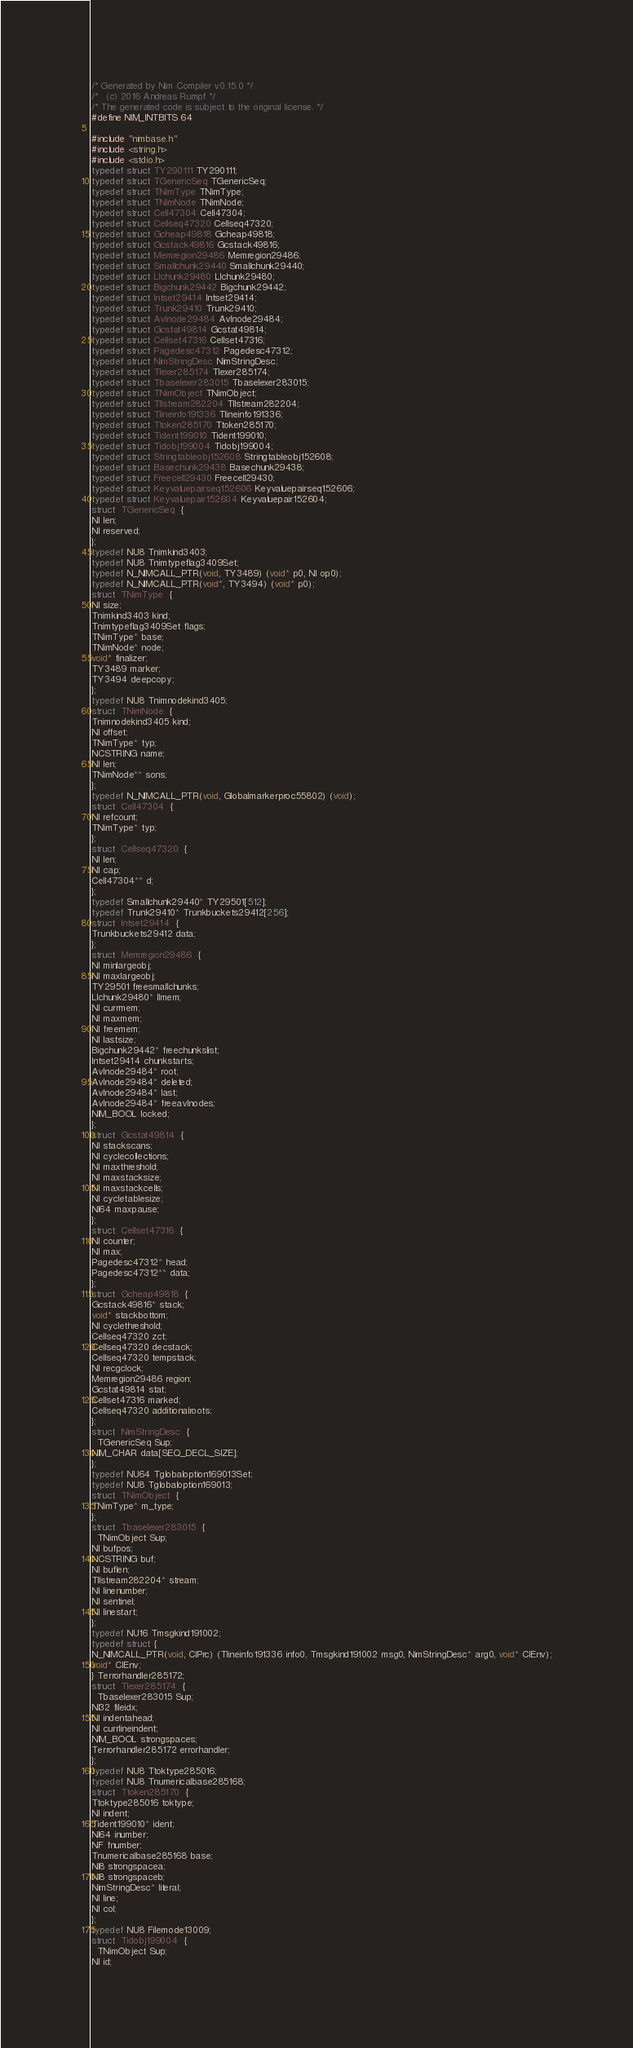Convert code to text. <code><loc_0><loc_0><loc_500><loc_500><_C_>/* Generated by Nim Compiler v0.15.0 */
/*   (c) 2016 Andreas Rumpf */
/* The generated code is subject to the original license. */
#define NIM_INTBITS 64

#include "nimbase.h"
#include <string.h>
#include <stdio.h>
typedef struct TY290111 TY290111;
typedef struct TGenericSeq TGenericSeq;
typedef struct TNimType TNimType;
typedef struct TNimNode TNimNode;
typedef struct Cell47304 Cell47304;
typedef struct Cellseq47320 Cellseq47320;
typedef struct Gcheap49818 Gcheap49818;
typedef struct Gcstack49816 Gcstack49816;
typedef struct Memregion29486 Memregion29486;
typedef struct Smallchunk29440 Smallchunk29440;
typedef struct Llchunk29480 Llchunk29480;
typedef struct Bigchunk29442 Bigchunk29442;
typedef struct Intset29414 Intset29414;
typedef struct Trunk29410 Trunk29410;
typedef struct Avlnode29484 Avlnode29484;
typedef struct Gcstat49814 Gcstat49814;
typedef struct Cellset47316 Cellset47316;
typedef struct Pagedesc47312 Pagedesc47312;
typedef struct NimStringDesc NimStringDesc;
typedef struct Tlexer285174 Tlexer285174;
typedef struct Tbaselexer283015 Tbaselexer283015;
typedef struct TNimObject TNimObject;
typedef struct Tllstream282204 Tllstream282204;
typedef struct Tlineinfo191336 Tlineinfo191336;
typedef struct Ttoken285170 Ttoken285170;
typedef struct Tident199010 Tident199010;
typedef struct Tidobj199004 Tidobj199004;
typedef struct Stringtableobj152608 Stringtableobj152608;
typedef struct Basechunk29438 Basechunk29438;
typedef struct Freecell29430 Freecell29430;
typedef struct Keyvaluepairseq152606 Keyvaluepairseq152606;
typedef struct Keyvaluepair152604 Keyvaluepair152604;
struct  TGenericSeq  {
NI len;
NI reserved;
};
typedef NU8 Tnimkind3403;
typedef NU8 Tnimtypeflag3409Set;
typedef N_NIMCALL_PTR(void, TY3489) (void* p0, NI op0);
typedef N_NIMCALL_PTR(void*, TY3494) (void* p0);
struct  TNimType  {
NI size;
Tnimkind3403 kind;
Tnimtypeflag3409Set flags;
TNimType* base;
TNimNode* node;
void* finalizer;
TY3489 marker;
TY3494 deepcopy;
};
typedef NU8 Tnimnodekind3405;
struct  TNimNode  {
Tnimnodekind3405 kind;
NI offset;
TNimType* typ;
NCSTRING name;
NI len;
TNimNode** sons;
};
typedef N_NIMCALL_PTR(void, Globalmarkerproc55802) (void);
struct  Cell47304  {
NI refcount;
TNimType* typ;
};
struct  Cellseq47320  {
NI len;
NI cap;
Cell47304** d;
};
typedef Smallchunk29440* TY29501[512];
typedef Trunk29410* Trunkbuckets29412[256];
struct  Intset29414  {
Trunkbuckets29412 data;
};
struct  Memregion29486  {
NI minlargeobj;
NI maxlargeobj;
TY29501 freesmallchunks;
Llchunk29480* llmem;
NI currmem;
NI maxmem;
NI freemem;
NI lastsize;
Bigchunk29442* freechunkslist;
Intset29414 chunkstarts;
Avlnode29484* root;
Avlnode29484* deleted;
Avlnode29484* last;
Avlnode29484* freeavlnodes;
NIM_BOOL locked;
};
struct  Gcstat49814  {
NI stackscans;
NI cyclecollections;
NI maxthreshold;
NI maxstacksize;
NI maxstackcells;
NI cycletablesize;
NI64 maxpause;
};
struct  Cellset47316  {
NI counter;
NI max;
Pagedesc47312* head;
Pagedesc47312** data;
};
struct  Gcheap49818  {
Gcstack49816* stack;
void* stackbottom;
NI cyclethreshold;
Cellseq47320 zct;
Cellseq47320 decstack;
Cellseq47320 tempstack;
NI recgclock;
Memregion29486 region;
Gcstat49814 stat;
Cellset47316 marked;
Cellseq47320 additionalroots;
};
struct  NimStringDesc  {
  TGenericSeq Sup;
NIM_CHAR data[SEQ_DECL_SIZE];
};
typedef NU64 Tglobaloption169013Set;
typedef NU8 Tglobaloption169013;
struct  TNimObject  {
TNimType* m_type;
};
struct  Tbaselexer283015  {
  TNimObject Sup;
NI bufpos;
NCSTRING buf;
NI buflen;
Tllstream282204* stream;
NI linenumber;
NI sentinel;
NI linestart;
};
typedef NU16 Tmsgkind191002;
typedef struct {
N_NIMCALL_PTR(void, ClPrc) (Tlineinfo191336 info0, Tmsgkind191002 msg0, NimStringDesc* arg0, void* ClEnv);
void* ClEnv;
} Terrorhandler285172;
struct  Tlexer285174  {
  Tbaselexer283015 Sup;
NI32 fileidx;
NI indentahead;
NI currlineindent;
NIM_BOOL strongspaces;
Terrorhandler285172 errorhandler;
};
typedef NU8 Ttoktype285016;
typedef NU8 Tnumericalbase285168;
struct  Ttoken285170  {
Ttoktype285016 toktype;
NI indent;
Tident199010* ident;
NI64 inumber;
NF fnumber;
Tnumericalbase285168 base;
NI8 strongspacea;
NI8 strongspaceb;
NimStringDesc* literal;
NI line;
NI col;
};
typedef NU8 Filemode13009;
struct  Tidobj199004  {
  TNimObject Sup;
NI id;</code> 